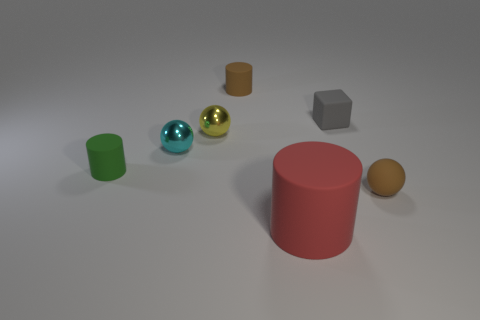There is another small cylinder that is made of the same material as the green cylinder; what is its color?
Your answer should be very brief. Brown. Is the number of brown rubber things behind the cyan metal ball less than the number of small matte spheres to the left of the small matte sphere?
Provide a short and direct response. No. What number of small yellow things are made of the same material as the tiny cyan thing?
Give a very brief answer. 1. Does the yellow ball have the same size as the cyan metal thing behind the small green rubber object?
Give a very brief answer. Yes. What material is the thing that is the same color as the tiny matte ball?
Offer a very short reply. Rubber. Are there more large matte things on the left side of the tiny gray rubber thing than small brown balls on the right side of the brown rubber sphere?
Provide a short and direct response. Yes. Are there any small cylinders of the same color as the small rubber sphere?
Ensure brevity in your answer.  Yes. Do the green matte cylinder and the rubber cube have the same size?
Keep it short and to the point. Yes. There is a small cyan object that is the same shape as the yellow shiny thing; what is its material?
Your response must be concise. Metal. The small thing that is both on the left side of the small yellow thing and to the right of the small green cylinder is made of what material?
Your response must be concise. Metal. 